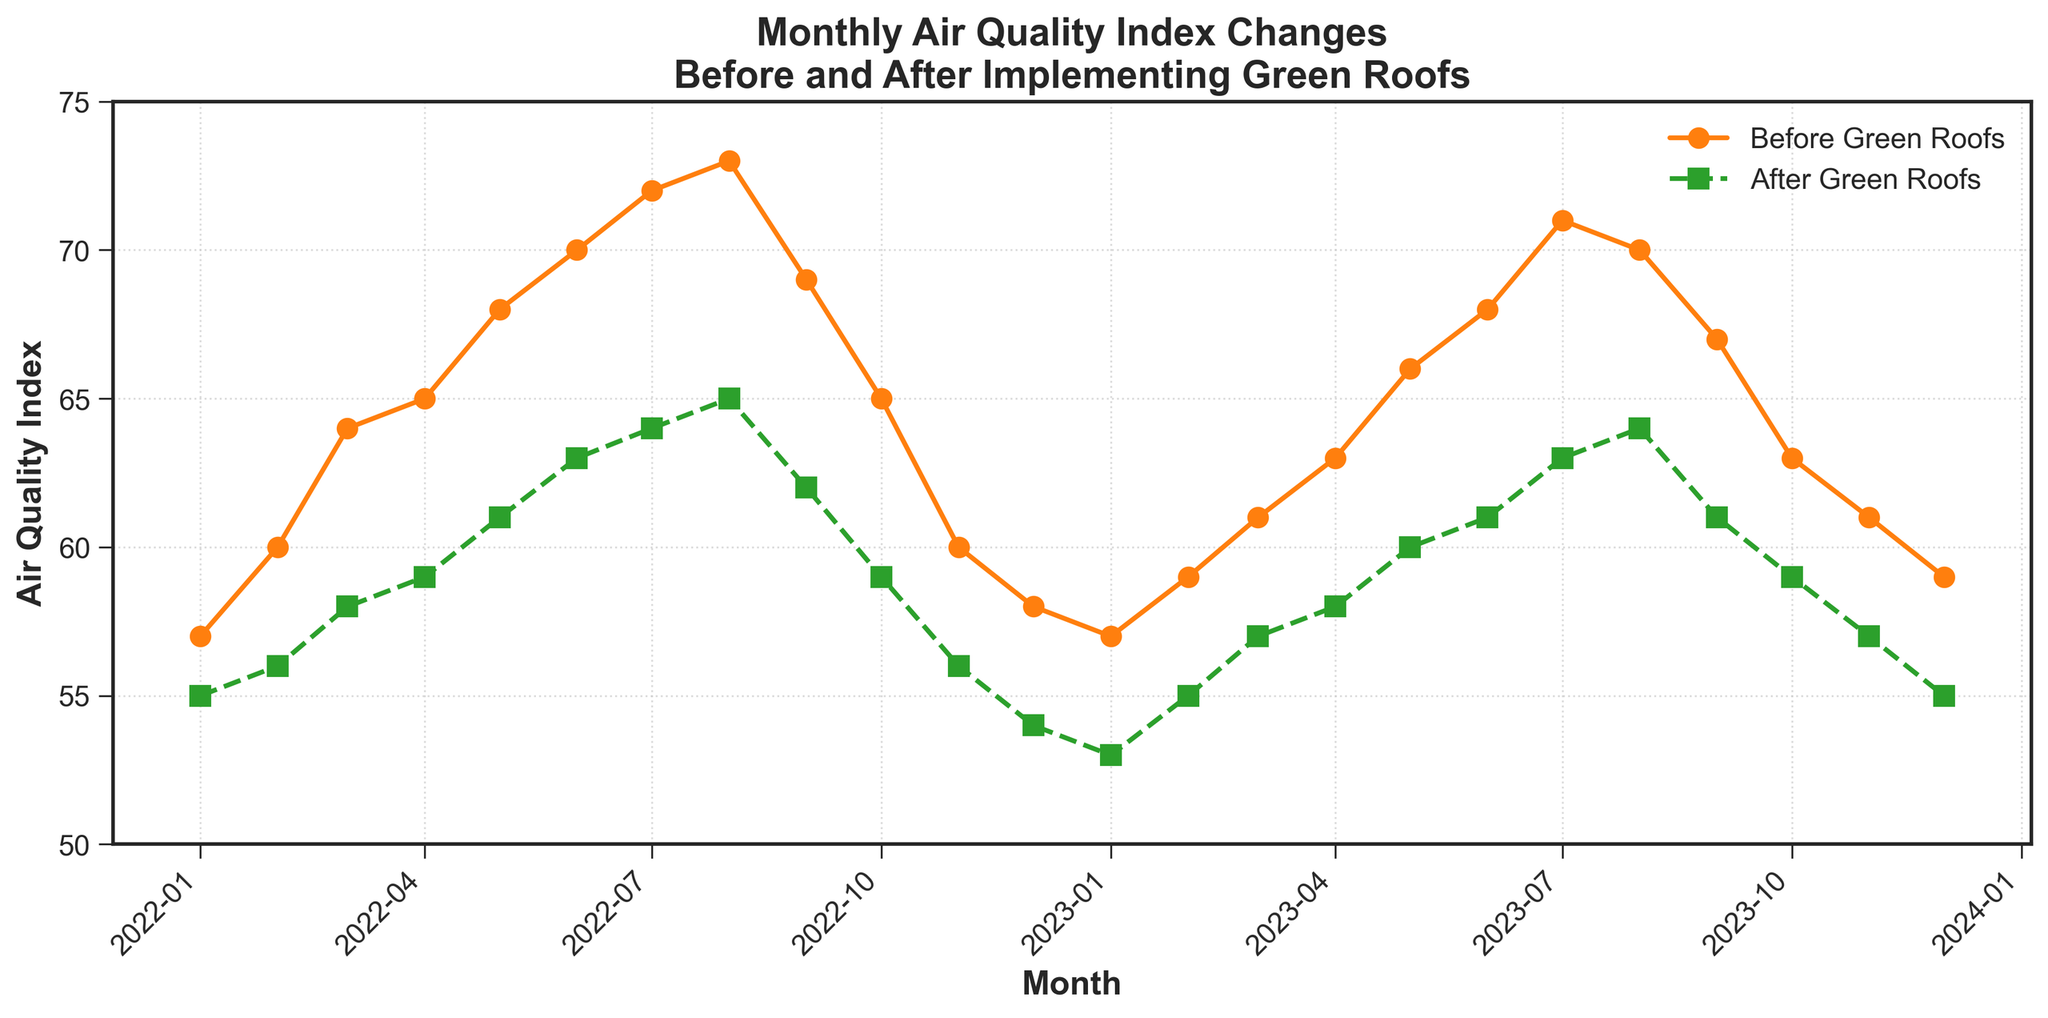What's the title of the plot? The title is the text displayed at the top, summarizing the content of the plot.
Answer: Monthly Air Quality Index Changes Before and After Implementing Green Roofs What does each line color represent? The legend indicates that the orange line represents air quality before green roofs and the green line represents air quality after green roofs.
Answer: Orange: Before Green Roofs, Green: After Green Roofs How many months are represented in the plot? Count the number of points, each corresponding to a distinct month along the x-axis. There are 24 data points, representing two years.
Answer: 24 What is the air quality index value in June 2022 before green roofs were implemented? Locate June 2022 on the x-axis and check the value of the orange line at that point.
Answer: 70 In which month does the air quality index drop below 60 after green roofs are implemented? Look at the green line and find the first month where the value is below 60.
Answer: January 2023 What is the average air quality index after implementing green roofs in all months of 2023? Add the air quality index values from January 2023 to December 2023 and divide by 12. (53+55+57+58+60+61+63+64+61+59+57+55)/12 = 59
Answer: 59 By how much did the air quality index improve on average from the same month in 2022 before green roofs were implemented to 2023 after green roofs were implemented? Calculate the difference for each month (from January to August, and from September to December, compare same months in the two years), then take the average. The differences are: 4 (57-53), 4 (59-55), 4 (61-57), 5 (63-58), 6 (66-60), 7 (68-61), 8 (71-63), 6 (70-64), 6 (69-62), 6 (65-59), 3 (60-57), 3 (58-55); Average: (4+4+4+5+6+7+8+6+6+6+3+3)/12 ≈ 5.33.
Answer: Approximately 5 Compare the air quality index in July 2022 and July 2023 before and after the implementation of green roofs, respectively. Locate the points for July in both years for both lines and compare their values. Before: July 2022 is 72, After: July 2023 is 63. So the air quality index decreased by 9 units.
Answer: 9 units decrease Which month showed the greatest improvement in air quality index after the implementation of green roofs? Find which month has the largest difference between the orange and green lines by subtracting the green values from the orange values for all months. The maximum difference is in July 2022: 9 (72-63).
Answer: July 2022 Describe the overall trend in air quality before and after the implementation of green roofs. Examine the direction of both lines over the entire period. Both indices show an increasing trend before green roofs and a generally decreasing trend after the intervention. This indicates an improvement in air quality over time after implementing green roofs.
Answer: Improvement over time after green roofs 